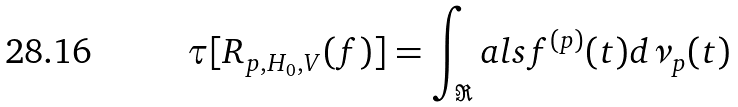<formula> <loc_0><loc_0><loc_500><loc_500>\tau [ R _ { p , H _ { 0 } , V } ( f ) ] = \int _ { \Re } a l s f ^ { ( p ) } ( t ) d \nu _ { p } ( t )</formula> 